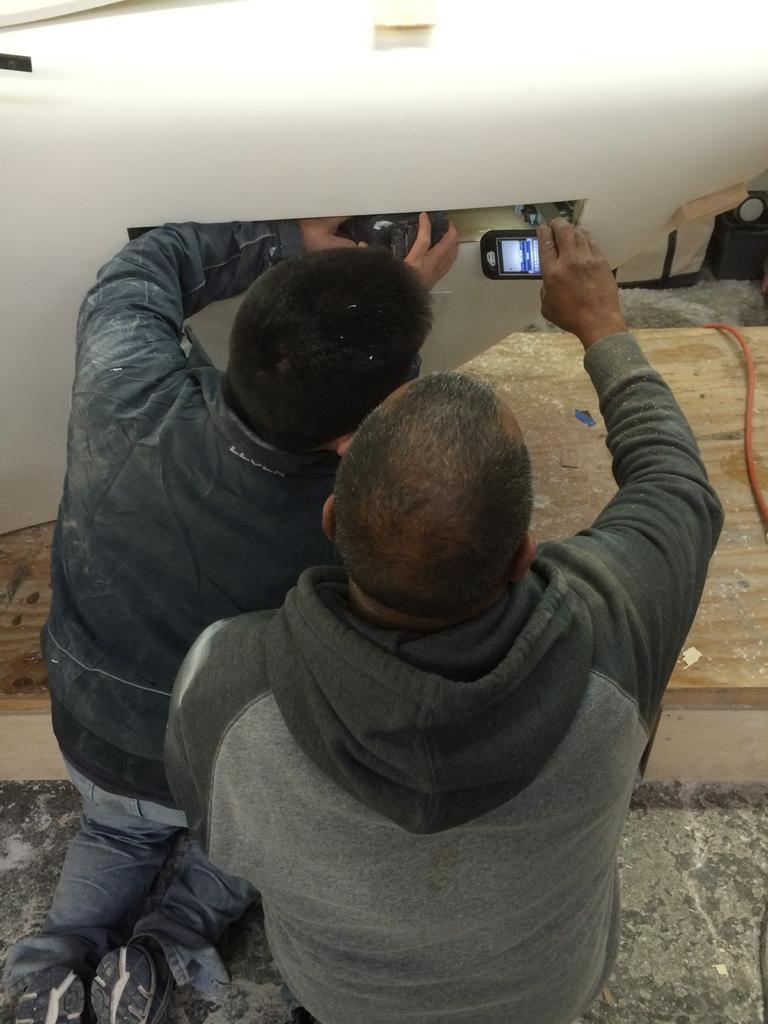Describe this image in one or two sentences. In this image two persons are on the floor. Right side person is holding a mobile in his hand. Beside him there is a person holding the machine which is on the wooden plank. Right side there is a wire on the wooden plank. 